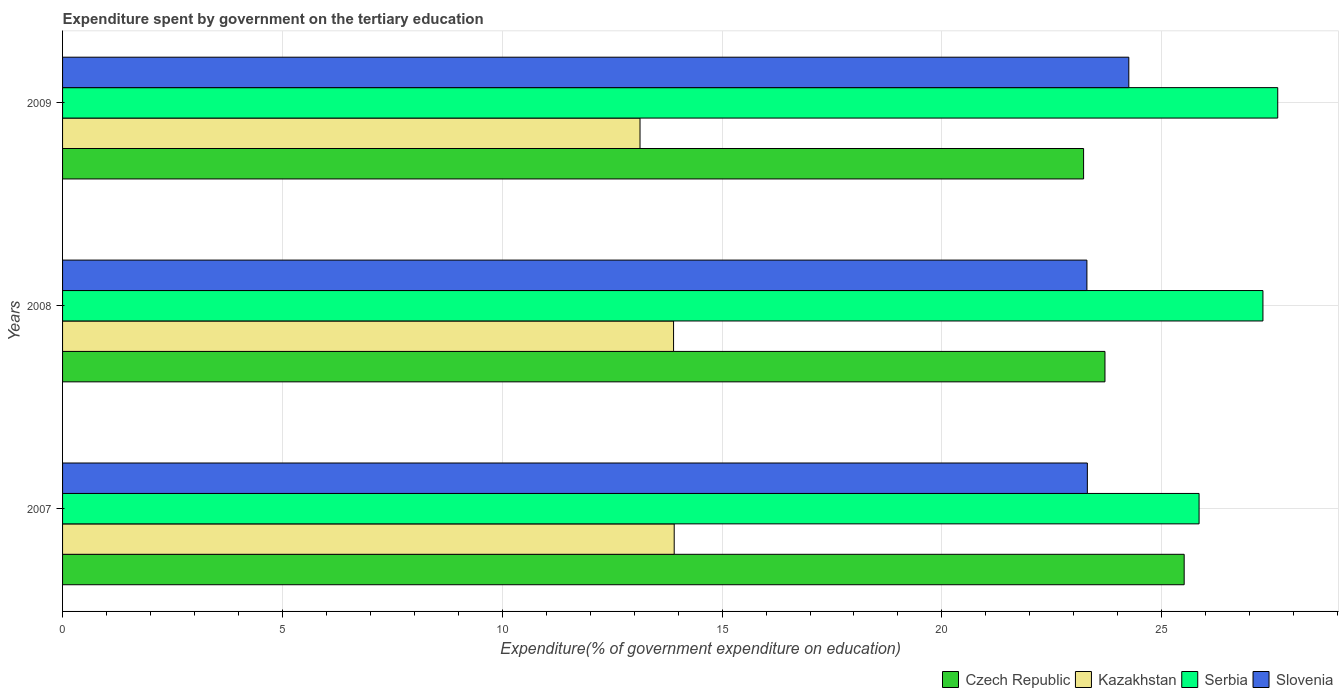How many different coloured bars are there?
Ensure brevity in your answer.  4. Are the number of bars per tick equal to the number of legend labels?
Keep it short and to the point. Yes. How many bars are there on the 1st tick from the top?
Keep it short and to the point. 4. How many bars are there on the 2nd tick from the bottom?
Your response must be concise. 4. What is the label of the 3rd group of bars from the top?
Your response must be concise. 2007. In how many cases, is the number of bars for a given year not equal to the number of legend labels?
Keep it short and to the point. 0. What is the expenditure spent by government on the tertiary education in Slovenia in 2008?
Keep it short and to the point. 23.3. Across all years, what is the maximum expenditure spent by government on the tertiary education in Czech Republic?
Provide a succinct answer. 25.51. Across all years, what is the minimum expenditure spent by government on the tertiary education in Slovenia?
Offer a very short reply. 23.3. In which year was the expenditure spent by government on the tertiary education in Czech Republic maximum?
Your answer should be very brief. 2007. In which year was the expenditure spent by government on the tertiary education in Serbia minimum?
Provide a succinct answer. 2007. What is the total expenditure spent by government on the tertiary education in Slovenia in the graph?
Keep it short and to the point. 70.86. What is the difference between the expenditure spent by government on the tertiary education in Czech Republic in 2008 and that in 2009?
Your answer should be compact. 0.49. What is the difference between the expenditure spent by government on the tertiary education in Kazakhstan in 2009 and the expenditure spent by government on the tertiary education in Slovenia in 2007?
Offer a terse response. -10.17. What is the average expenditure spent by government on the tertiary education in Czech Republic per year?
Your answer should be compact. 24.15. In the year 2008, what is the difference between the expenditure spent by government on the tertiary education in Serbia and expenditure spent by government on the tertiary education in Kazakhstan?
Keep it short and to the point. 13.41. What is the ratio of the expenditure spent by government on the tertiary education in Slovenia in 2008 to that in 2009?
Your answer should be compact. 0.96. What is the difference between the highest and the second highest expenditure spent by government on the tertiary education in Czech Republic?
Provide a short and direct response. 1.8. What is the difference between the highest and the lowest expenditure spent by government on the tertiary education in Slovenia?
Keep it short and to the point. 0.95. In how many years, is the expenditure spent by government on the tertiary education in Kazakhstan greater than the average expenditure spent by government on the tertiary education in Kazakhstan taken over all years?
Give a very brief answer. 2. Is the sum of the expenditure spent by government on the tertiary education in Slovenia in 2007 and 2009 greater than the maximum expenditure spent by government on the tertiary education in Kazakhstan across all years?
Your response must be concise. Yes. What does the 1st bar from the top in 2007 represents?
Give a very brief answer. Slovenia. What does the 1st bar from the bottom in 2008 represents?
Provide a succinct answer. Czech Republic. Is it the case that in every year, the sum of the expenditure spent by government on the tertiary education in Slovenia and expenditure spent by government on the tertiary education in Czech Republic is greater than the expenditure spent by government on the tertiary education in Kazakhstan?
Your answer should be very brief. Yes. How many years are there in the graph?
Your answer should be very brief. 3. What is the difference between two consecutive major ticks on the X-axis?
Your answer should be compact. 5. Are the values on the major ticks of X-axis written in scientific E-notation?
Give a very brief answer. No. Does the graph contain any zero values?
Keep it short and to the point. No. Does the graph contain grids?
Give a very brief answer. Yes. Where does the legend appear in the graph?
Keep it short and to the point. Bottom right. What is the title of the graph?
Give a very brief answer. Expenditure spent by government on the tertiary education. Does "Egypt, Arab Rep." appear as one of the legend labels in the graph?
Ensure brevity in your answer.  No. What is the label or title of the X-axis?
Offer a terse response. Expenditure(% of government expenditure on education). What is the label or title of the Y-axis?
Offer a very short reply. Years. What is the Expenditure(% of government expenditure on education) in Czech Republic in 2007?
Your response must be concise. 25.51. What is the Expenditure(% of government expenditure on education) of Kazakhstan in 2007?
Provide a short and direct response. 13.91. What is the Expenditure(% of government expenditure on education) of Serbia in 2007?
Your answer should be compact. 25.85. What is the Expenditure(% of government expenditure on education) of Slovenia in 2007?
Provide a short and direct response. 23.31. What is the Expenditure(% of government expenditure on education) of Czech Republic in 2008?
Your answer should be very brief. 23.71. What is the Expenditure(% of government expenditure on education) of Kazakhstan in 2008?
Ensure brevity in your answer.  13.9. What is the Expenditure(% of government expenditure on education) of Serbia in 2008?
Provide a short and direct response. 27.3. What is the Expenditure(% of government expenditure on education) of Slovenia in 2008?
Provide a succinct answer. 23.3. What is the Expenditure(% of government expenditure on education) in Czech Republic in 2009?
Make the answer very short. 23.22. What is the Expenditure(% of government expenditure on education) in Kazakhstan in 2009?
Your answer should be compact. 13.13. What is the Expenditure(% of government expenditure on education) in Serbia in 2009?
Provide a succinct answer. 27.64. What is the Expenditure(% of government expenditure on education) of Slovenia in 2009?
Your answer should be very brief. 24.25. Across all years, what is the maximum Expenditure(% of government expenditure on education) of Czech Republic?
Offer a very short reply. 25.51. Across all years, what is the maximum Expenditure(% of government expenditure on education) in Kazakhstan?
Provide a short and direct response. 13.91. Across all years, what is the maximum Expenditure(% of government expenditure on education) in Serbia?
Offer a very short reply. 27.64. Across all years, what is the maximum Expenditure(% of government expenditure on education) in Slovenia?
Make the answer very short. 24.25. Across all years, what is the minimum Expenditure(% of government expenditure on education) of Czech Republic?
Your answer should be very brief. 23.22. Across all years, what is the minimum Expenditure(% of government expenditure on education) of Kazakhstan?
Your response must be concise. 13.13. Across all years, what is the minimum Expenditure(% of government expenditure on education) of Serbia?
Your answer should be very brief. 25.85. Across all years, what is the minimum Expenditure(% of government expenditure on education) in Slovenia?
Your answer should be very brief. 23.3. What is the total Expenditure(% of government expenditure on education) in Czech Republic in the graph?
Offer a terse response. 72.44. What is the total Expenditure(% of government expenditure on education) in Kazakhstan in the graph?
Your response must be concise. 40.94. What is the total Expenditure(% of government expenditure on education) of Serbia in the graph?
Keep it short and to the point. 80.79. What is the total Expenditure(% of government expenditure on education) in Slovenia in the graph?
Give a very brief answer. 70.86. What is the difference between the Expenditure(% of government expenditure on education) in Czech Republic in 2007 and that in 2008?
Your answer should be compact. 1.8. What is the difference between the Expenditure(% of government expenditure on education) of Kazakhstan in 2007 and that in 2008?
Ensure brevity in your answer.  0.01. What is the difference between the Expenditure(% of government expenditure on education) of Serbia in 2007 and that in 2008?
Make the answer very short. -1.45. What is the difference between the Expenditure(% of government expenditure on education) of Slovenia in 2007 and that in 2008?
Your answer should be compact. 0.01. What is the difference between the Expenditure(% of government expenditure on education) in Czech Republic in 2007 and that in 2009?
Give a very brief answer. 2.29. What is the difference between the Expenditure(% of government expenditure on education) in Kazakhstan in 2007 and that in 2009?
Your response must be concise. 0.78. What is the difference between the Expenditure(% of government expenditure on education) of Serbia in 2007 and that in 2009?
Offer a terse response. -1.79. What is the difference between the Expenditure(% of government expenditure on education) of Slovenia in 2007 and that in 2009?
Provide a succinct answer. -0.94. What is the difference between the Expenditure(% of government expenditure on education) of Czech Republic in 2008 and that in 2009?
Keep it short and to the point. 0.49. What is the difference between the Expenditure(% of government expenditure on education) in Kazakhstan in 2008 and that in 2009?
Provide a short and direct response. 0.76. What is the difference between the Expenditure(% of government expenditure on education) in Serbia in 2008 and that in 2009?
Offer a very short reply. -0.34. What is the difference between the Expenditure(% of government expenditure on education) of Slovenia in 2008 and that in 2009?
Ensure brevity in your answer.  -0.95. What is the difference between the Expenditure(% of government expenditure on education) in Czech Republic in 2007 and the Expenditure(% of government expenditure on education) in Kazakhstan in 2008?
Provide a short and direct response. 11.61. What is the difference between the Expenditure(% of government expenditure on education) of Czech Republic in 2007 and the Expenditure(% of government expenditure on education) of Serbia in 2008?
Provide a short and direct response. -1.79. What is the difference between the Expenditure(% of government expenditure on education) in Czech Republic in 2007 and the Expenditure(% of government expenditure on education) in Slovenia in 2008?
Your response must be concise. 2.21. What is the difference between the Expenditure(% of government expenditure on education) of Kazakhstan in 2007 and the Expenditure(% of government expenditure on education) of Serbia in 2008?
Keep it short and to the point. -13.39. What is the difference between the Expenditure(% of government expenditure on education) in Kazakhstan in 2007 and the Expenditure(% of government expenditure on education) in Slovenia in 2008?
Ensure brevity in your answer.  -9.39. What is the difference between the Expenditure(% of government expenditure on education) of Serbia in 2007 and the Expenditure(% of government expenditure on education) of Slovenia in 2008?
Your response must be concise. 2.55. What is the difference between the Expenditure(% of government expenditure on education) of Czech Republic in 2007 and the Expenditure(% of government expenditure on education) of Kazakhstan in 2009?
Make the answer very short. 12.38. What is the difference between the Expenditure(% of government expenditure on education) in Czech Republic in 2007 and the Expenditure(% of government expenditure on education) in Serbia in 2009?
Keep it short and to the point. -2.13. What is the difference between the Expenditure(% of government expenditure on education) of Czech Republic in 2007 and the Expenditure(% of government expenditure on education) of Slovenia in 2009?
Keep it short and to the point. 1.26. What is the difference between the Expenditure(% of government expenditure on education) in Kazakhstan in 2007 and the Expenditure(% of government expenditure on education) in Serbia in 2009?
Keep it short and to the point. -13.73. What is the difference between the Expenditure(% of government expenditure on education) of Kazakhstan in 2007 and the Expenditure(% of government expenditure on education) of Slovenia in 2009?
Keep it short and to the point. -10.34. What is the difference between the Expenditure(% of government expenditure on education) in Serbia in 2007 and the Expenditure(% of government expenditure on education) in Slovenia in 2009?
Give a very brief answer. 1.6. What is the difference between the Expenditure(% of government expenditure on education) in Czech Republic in 2008 and the Expenditure(% of government expenditure on education) in Kazakhstan in 2009?
Provide a succinct answer. 10.58. What is the difference between the Expenditure(% of government expenditure on education) in Czech Republic in 2008 and the Expenditure(% of government expenditure on education) in Serbia in 2009?
Provide a succinct answer. -3.93. What is the difference between the Expenditure(% of government expenditure on education) of Czech Republic in 2008 and the Expenditure(% of government expenditure on education) of Slovenia in 2009?
Offer a very short reply. -0.54. What is the difference between the Expenditure(% of government expenditure on education) in Kazakhstan in 2008 and the Expenditure(% of government expenditure on education) in Serbia in 2009?
Offer a terse response. -13.74. What is the difference between the Expenditure(% of government expenditure on education) in Kazakhstan in 2008 and the Expenditure(% of government expenditure on education) in Slovenia in 2009?
Offer a terse response. -10.35. What is the difference between the Expenditure(% of government expenditure on education) in Serbia in 2008 and the Expenditure(% of government expenditure on education) in Slovenia in 2009?
Provide a short and direct response. 3.05. What is the average Expenditure(% of government expenditure on education) of Czech Republic per year?
Offer a very short reply. 24.15. What is the average Expenditure(% of government expenditure on education) in Kazakhstan per year?
Make the answer very short. 13.65. What is the average Expenditure(% of government expenditure on education) of Serbia per year?
Provide a succinct answer. 26.93. What is the average Expenditure(% of government expenditure on education) of Slovenia per year?
Offer a terse response. 23.62. In the year 2007, what is the difference between the Expenditure(% of government expenditure on education) in Czech Republic and Expenditure(% of government expenditure on education) in Kazakhstan?
Make the answer very short. 11.6. In the year 2007, what is the difference between the Expenditure(% of government expenditure on education) in Czech Republic and Expenditure(% of government expenditure on education) in Serbia?
Your answer should be compact. -0.34. In the year 2007, what is the difference between the Expenditure(% of government expenditure on education) in Czech Republic and Expenditure(% of government expenditure on education) in Slovenia?
Your answer should be compact. 2.2. In the year 2007, what is the difference between the Expenditure(% of government expenditure on education) of Kazakhstan and Expenditure(% of government expenditure on education) of Serbia?
Your answer should be compact. -11.94. In the year 2007, what is the difference between the Expenditure(% of government expenditure on education) in Kazakhstan and Expenditure(% of government expenditure on education) in Slovenia?
Ensure brevity in your answer.  -9.4. In the year 2007, what is the difference between the Expenditure(% of government expenditure on education) in Serbia and Expenditure(% of government expenditure on education) in Slovenia?
Your response must be concise. 2.54. In the year 2008, what is the difference between the Expenditure(% of government expenditure on education) of Czech Republic and Expenditure(% of government expenditure on education) of Kazakhstan?
Provide a succinct answer. 9.81. In the year 2008, what is the difference between the Expenditure(% of government expenditure on education) in Czech Republic and Expenditure(% of government expenditure on education) in Serbia?
Your answer should be compact. -3.59. In the year 2008, what is the difference between the Expenditure(% of government expenditure on education) in Czech Republic and Expenditure(% of government expenditure on education) in Slovenia?
Provide a short and direct response. 0.41. In the year 2008, what is the difference between the Expenditure(% of government expenditure on education) of Kazakhstan and Expenditure(% of government expenditure on education) of Serbia?
Give a very brief answer. -13.41. In the year 2008, what is the difference between the Expenditure(% of government expenditure on education) of Kazakhstan and Expenditure(% of government expenditure on education) of Slovenia?
Your answer should be very brief. -9.4. In the year 2008, what is the difference between the Expenditure(% of government expenditure on education) in Serbia and Expenditure(% of government expenditure on education) in Slovenia?
Keep it short and to the point. 4. In the year 2009, what is the difference between the Expenditure(% of government expenditure on education) in Czech Republic and Expenditure(% of government expenditure on education) in Kazakhstan?
Keep it short and to the point. 10.09. In the year 2009, what is the difference between the Expenditure(% of government expenditure on education) in Czech Republic and Expenditure(% of government expenditure on education) in Serbia?
Your response must be concise. -4.42. In the year 2009, what is the difference between the Expenditure(% of government expenditure on education) in Czech Republic and Expenditure(% of government expenditure on education) in Slovenia?
Your response must be concise. -1.03. In the year 2009, what is the difference between the Expenditure(% of government expenditure on education) of Kazakhstan and Expenditure(% of government expenditure on education) of Serbia?
Your answer should be compact. -14.5. In the year 2009, what is the difference between the Expenditure(% of government expenditure on education) of Kazakhstan and Expenditure(% of government expenditure on education) of Slovenia?
Provide a succinct answer. -11.12. In the year 2009, what is the difference between the Expenditure(% of government expenditure on education) of Serbia and Expenditure(% of government expenditure on education) of Slovenia?
Offer a very short reply. 3.39. What is the ratio of the Expenditure(% of government expenditure on education) of Czech Republic in 2007 to that in 2008?
Your response must be concise. 1.08. What is the ratio of the Expenditure(% of government expenditure on education) of Kazakhstan in 2007 to that in 2008?
Provide a succinct answer. 1. What is the ratio of the Expenditure(% of government expenditure on education) of Serbia in 2007 to that in 2008?
Your answer should be very brief. 0.95. What is the ratio of the Expenditure(% of government expenditure on education) in Czech Republic in 2007 to that in 2009?
Offer a terse response. 1.1. What is the ratio of the Expenditure(% of government expenditure on education) in Kazakhstan in 2007 to that in 2009?
Ensure brevity in your answer.  1.06. What is the ratio of the Expenditure(% of government expenditure on education) of Serbia in 2007 to that in 2009?
Offer a very short reply. 0.94. What is the ratio of the Expenditure(% of government expenditure on education) in Slovenia in 2007 to that in 2009?
Keep it short and to the point. 0.96. What is the ratio of the Expenditure(% of government expenditure on education) of Czech Republic in 2008 to that in 2009?
Provide a succinct answer. 1.02. What is the ratio of the Expenditure(% of government expenditure on education) of Kazakhstan in 2008 to that in 2009?
Your response must be concise. 1.06. What is the ratio of the Expenditure(% of government expenditure on education) of Slovenia in 2008 to that in 2009?
Your response must be concise. 0.96. What is the difference between the highest and the second highest Expenditure(% of government expenditure on education) of Czech Republic?
Keep it short and to the point. 1.8. What is the difference between the highest and the second highest Expenditure(% of government expenditure on education) of Kazakhstan?
Offer a very short reply. 0.01. What is the difference between the highest and the second highest Expenditure(% of government expenditure on education) of Serbia?
Ensure brevity in your answer.  0.34. What is the difference between the highest and the second highest Expenditure(% of government expenditure on education) in Slovenia?
Offer a terse response. 0.94. What is the difference between the highest and the lowest Expenditure(% of government expenditure on education) of Czech Republic?
Ensure brevity in your answer.  2.29. What is the difference between the highest and the lowest Expenditure(% of government expenditure on education) of Kazakhstan?
Offer a very short reply. 0.78. What is the difference between the highest and the lowest Expenditure(% of government expenditure on education) in Serbia?
Provide a succinct answer. 1.79. What is the difference between the highest and the lowest Expenditure(% of government expenditure on education) of Slovenia?
Your answer should be compact. 0.95. 